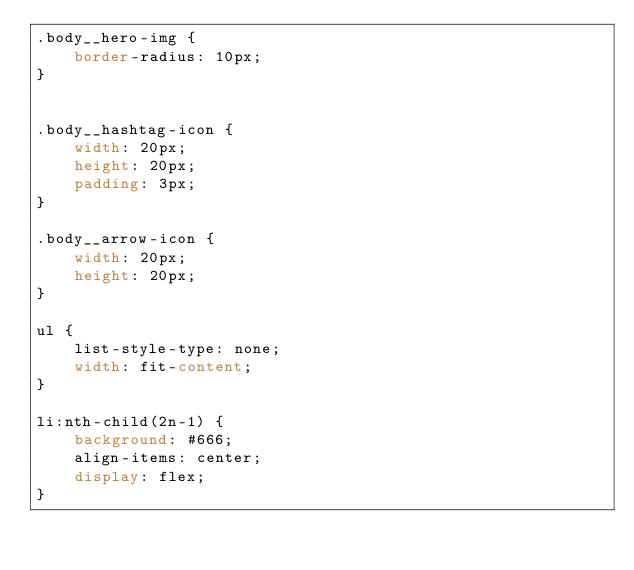Convert code to text. <code><loc_0><loc_0><loc_500><loc_500><_CSS_>.body__hero-img {
    border-radius: 10px;
}


.body__hashtag-icon {
    width: 20px;
    height: 20px;
    padding: 3px;
}

.body__arrow-icon {
    width: 20px;
    height: 20px;
}

ul {
    list-style-type: none;
    width: fit-content;
}

li:nth-child(2n-1) {
    background: #666;
    align-items: center;
    display: flex;
} </code> 